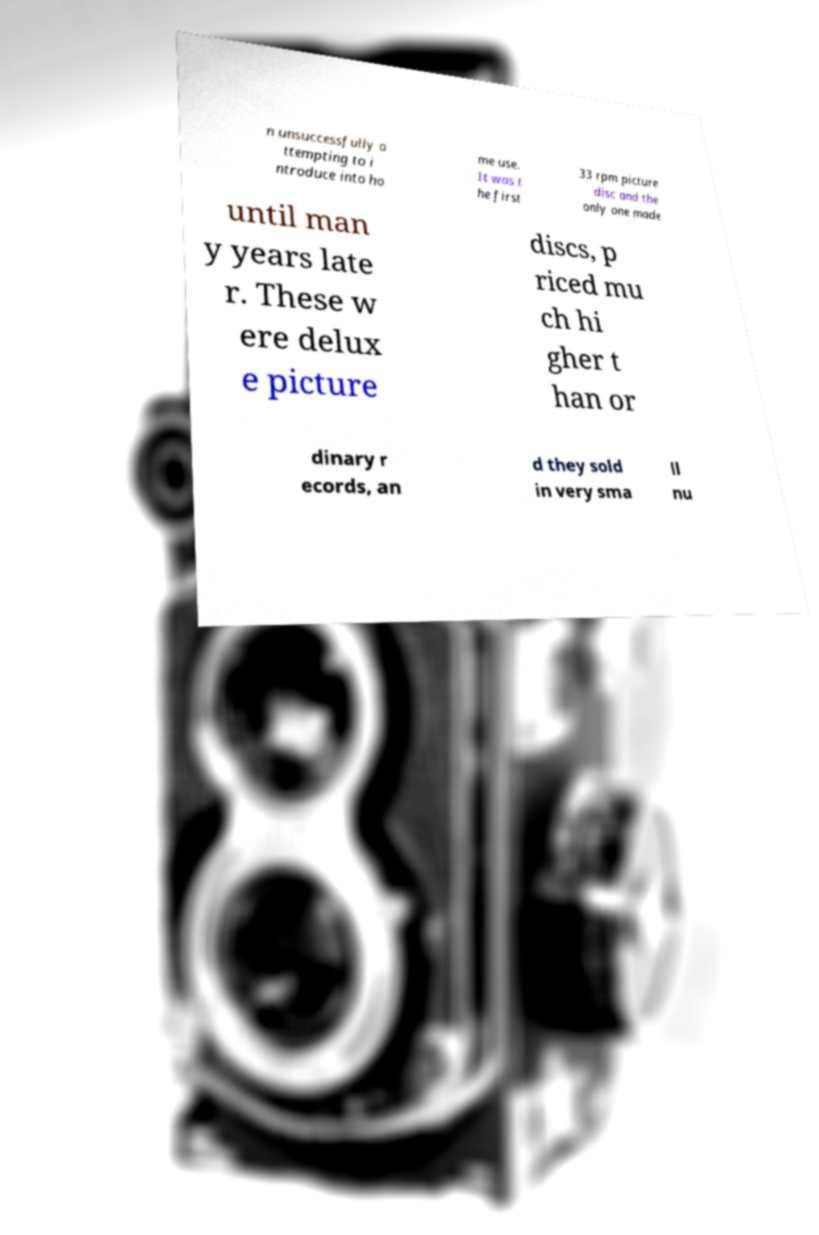I need the written content from this picture converted into text. Can you do that? n unsuccessfully a ttempting to i ntroduce into ho me use. It was t he first 33 rpm picture disc and the only one made until man y years late r. These w ere delux e picture discs, p riced mu ch hi gher t han or dinary r ecords, an d they sold in very sma ll nu 